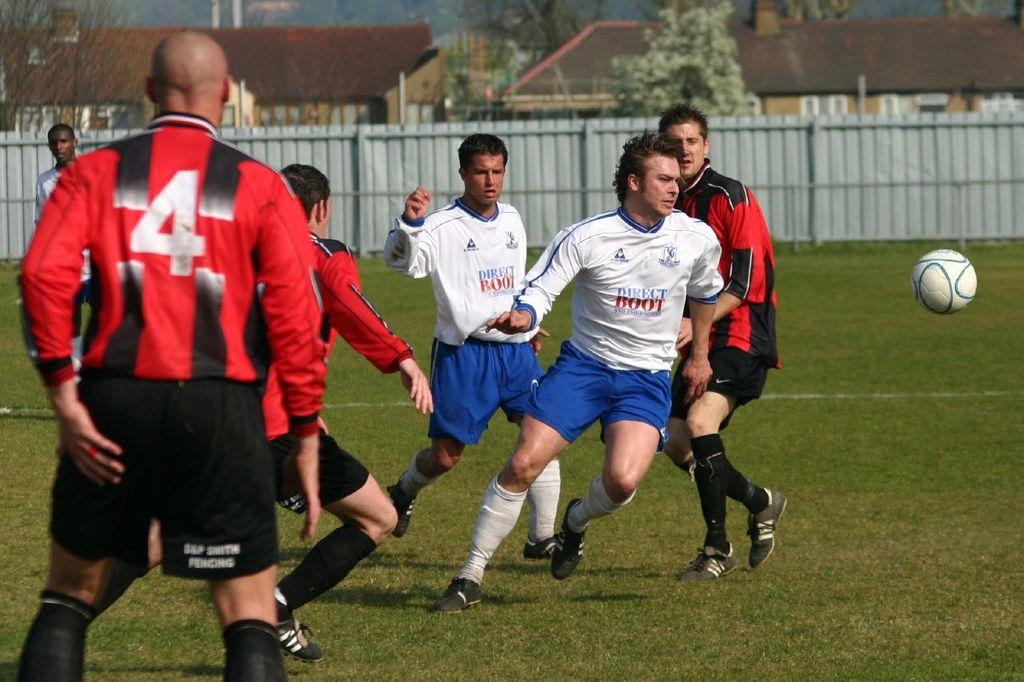<image>
Create a compact narrative representing the image presented. soccer players with white Direct Boot jerseys and red and black striped jerseys playing a game 